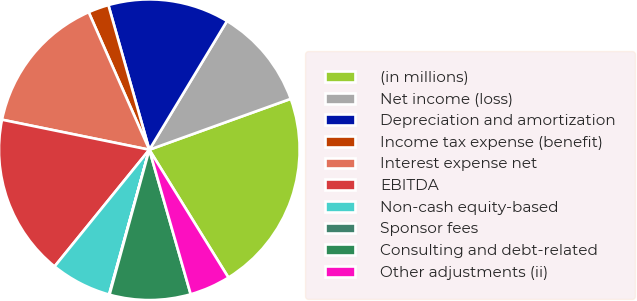Convert chart. <chart><loc_0><loc_0><loc_500><loc_500><pie_chart><fcel>(in millions)<fcel>Net income (loss)<fcel>Depreciation and amortization<fcel>Income tax expense (benefit)<fcel>Interest expense net<fcel>EBITDA<fcel>Non-cash equity-based<fcel>Sponsor fees<fcel>Consulting and debt-related<fcel>Other adjustments (ii)<nl><fcel>21.68%<fcel>10.86%<fcel>13.03%<fcel>2.22%<fcel>15.19%<fcel>17.35%<fcel>6.54%<fcel>0.05%<fcel>8.7%<fcel>4.38%<nl></chart> 